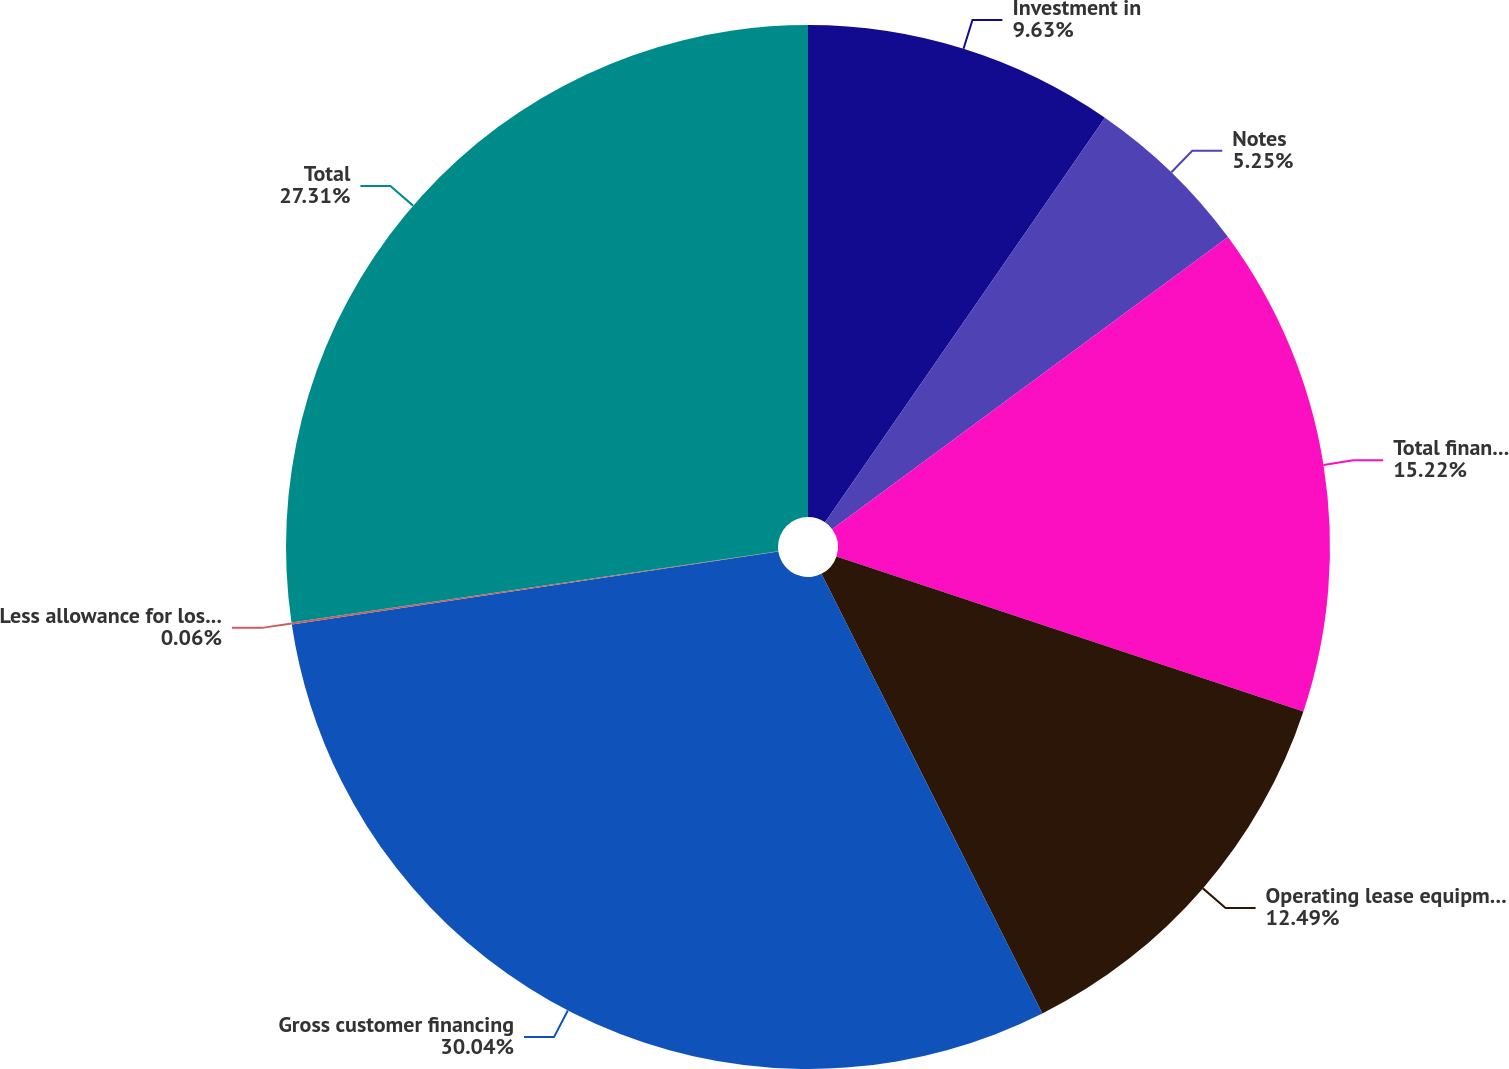<chart> <loc_0><loc_0><loc_500><loc_500><pie_chart><fcel>Investment in<fcel>Notes<fcel>Total financing receivables<fcel>Operating lease equipment at<fcel>Gross customer financing<fcel>Less allowance for losses on<fcel>Total<nl><fcel>9.63%<fcel>5.25%<fcel>15.22%<fcel>12.49%<fcel>30.04%<fcel>0.06%<fcel>27.31%<nl></chart> 